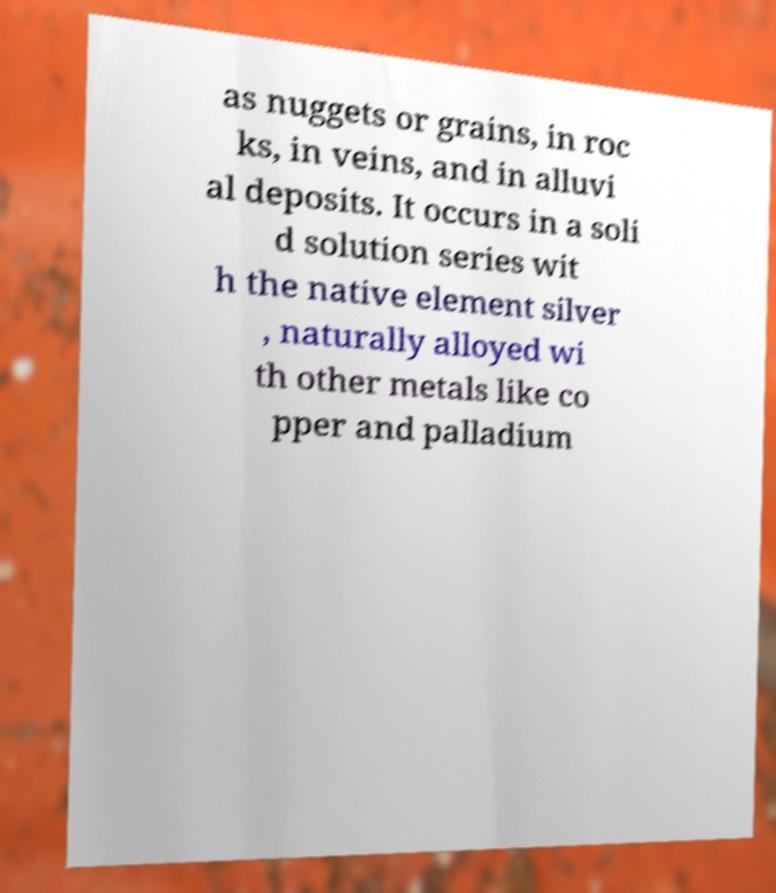Please identify and transcribe the text found in this image. as nuggets or grains, in roc ks, in veins, and in alluvi al deposits. It occurs in a soli d solution series wit h the native element silver , naturally alloyed wi th other metals like co pper and palladium 